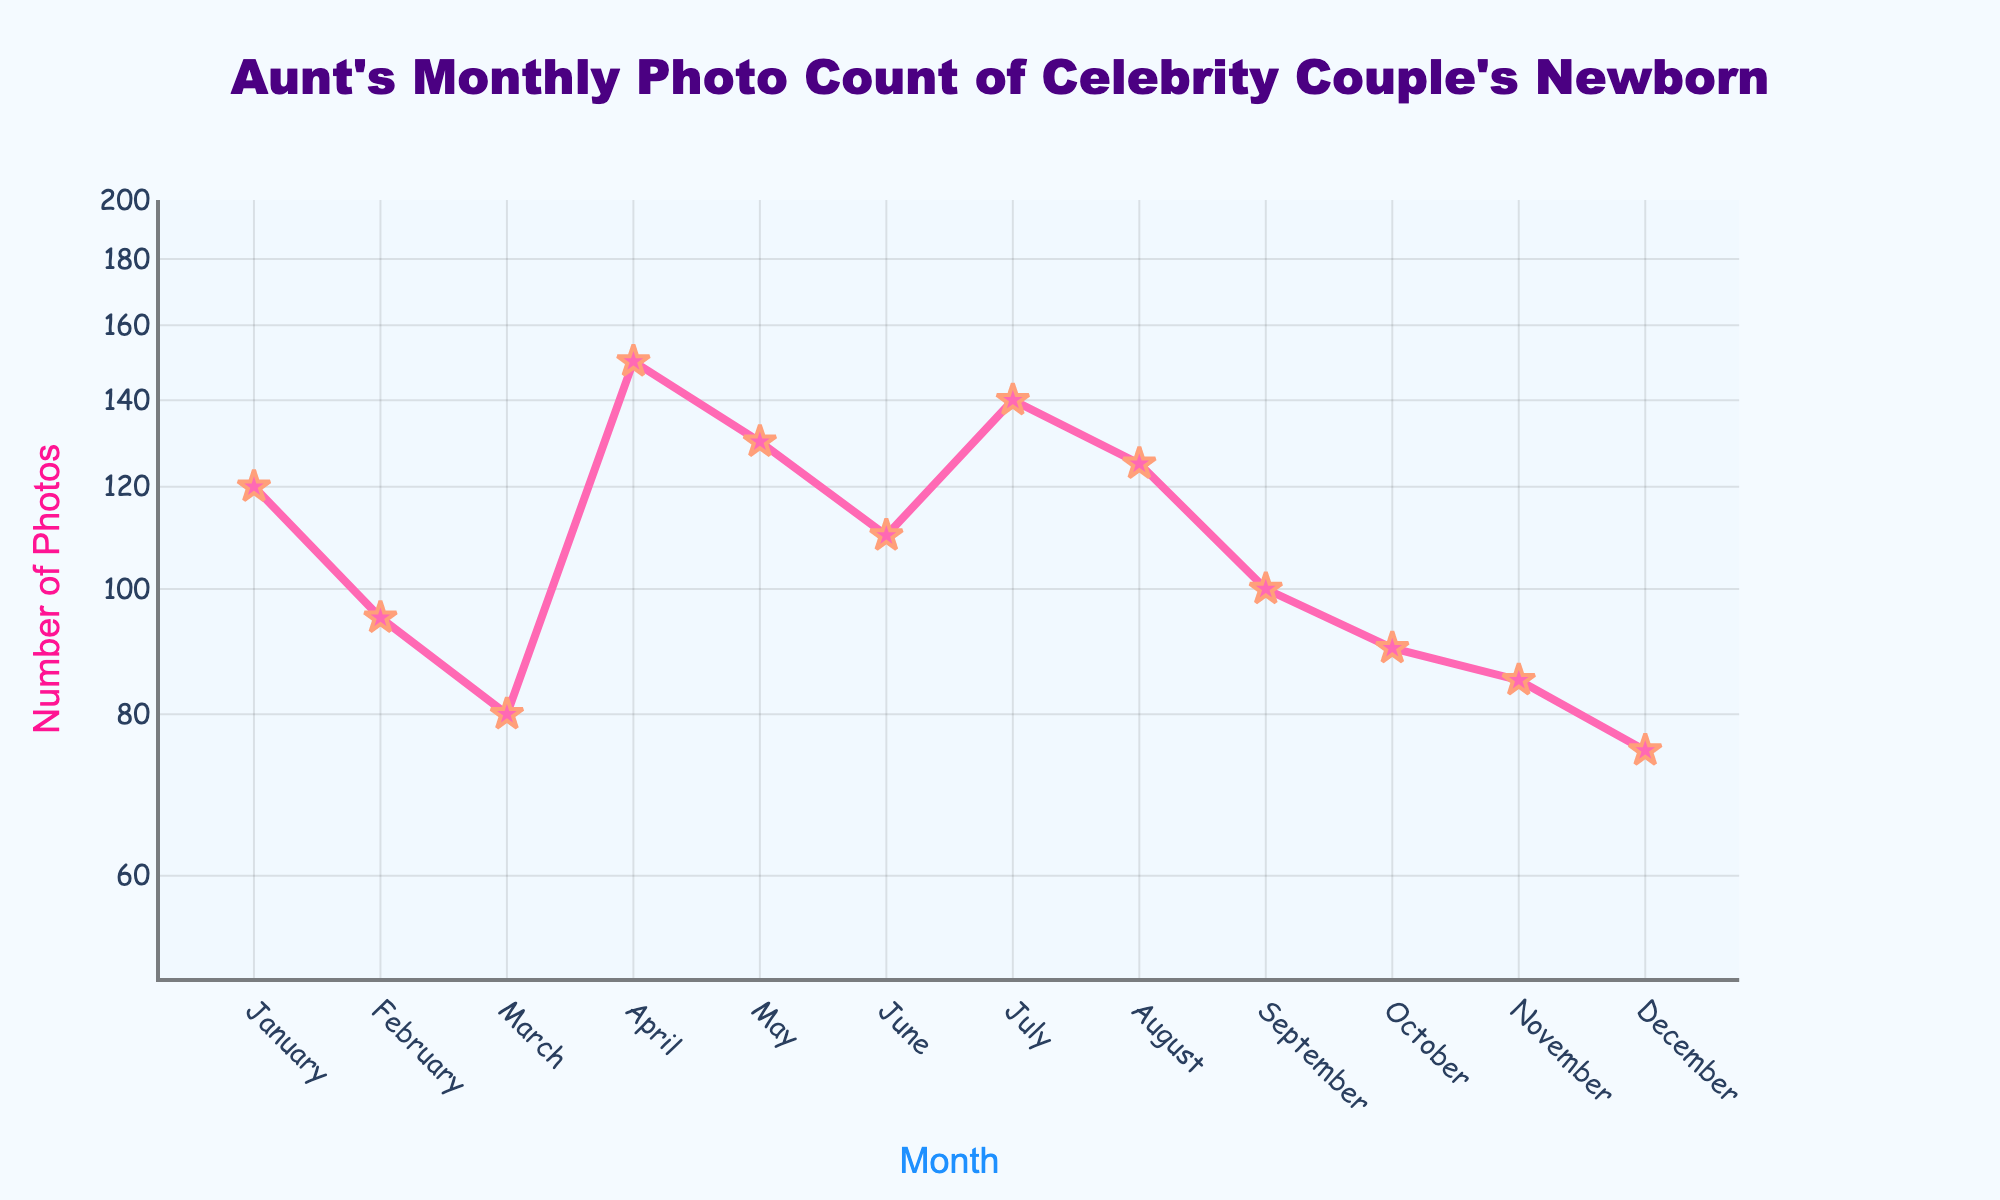Which month had the highest number of photos taken? According to the line plot, April had the highest number of photos with 150 photos taken.
Answer: April Which month saw the least number of photos taken? The line plot shows that December had the least number of photos taken with only 75 photos.
Answer: December What is the color of the line that represents the number of photos? The line plot uses a pink color for the line representing the number of photos.
Answer: Pink How does the number of photos taken in February compare to January? In January, 120 photos were taken, while in February, 95 photos were taken. February had 25 fewer photos than January.
Answer: 25 fewer What is the total number of photos taken from March to May? The line plot indicates that in March 80 photos, in April 150 photos, and in May 130 photos were taken. Adding them up: 80 + 150 + 130 = 360 photos.
Answer: 360 What is the average number of photos taken per month over the year? Summing all monthly photos (120 + 95 + 80 + 150 + 130 + 110 + 140 + 125 + 100 + 90 + 85 + 75) equals 1300. Dividing by 12 months gives an average of 1300 / 12 ≈ 108.33.
Answer: 108.33 Which three months have the closest number of photos taken? Looking at the line plot, November (85), March (80), and December (75) have close photo counts. The difference between November and March is 5 photos, and between March and December is 5 photos.
Answer: November, March, December How many months had fewer than 100 photos taken? The line plot shows February (95), March (80), September (100), October (90), November (85), December (75), making it 6 months with fewer than 100 photos taken.
Answer: 6 What trend do you observe in the number of photos taken from July to October? From July (140) to August (125) to September (100) to October (90), the number of photos taken steadily decreases each month.
Answer: Decreasing trend 